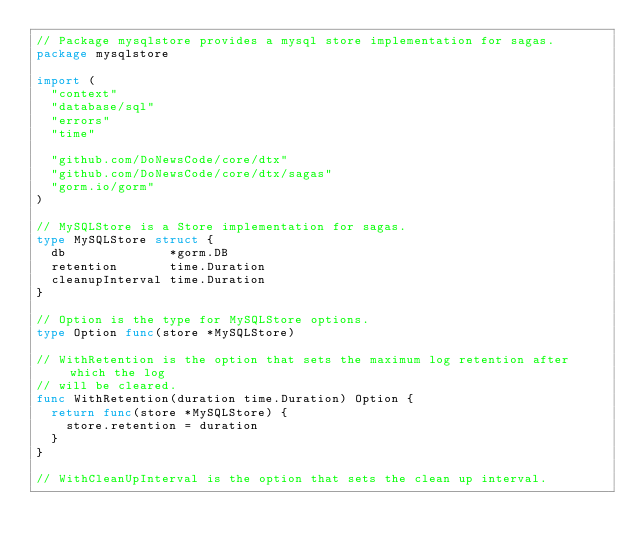<code> <loc_0><loc_0><loc_500><loc_500><_Go_>// Package mysqlstore provides a mysql store implementation for sagas.
package mysqlstore

import (
	"context"
	"database/sql"
	"errors"
	"time"

	"github.com/DoNewsCode/core/dtx"
	"github.com/DoNewsCode/core/dtx/sagas"
	"gorm.io/gorm"
)

// MySQLStore is a Store implementation for sagas.
type MySQLStore struct {
	db              *gorm.DB
	retention       time.Duration
	cleanupInterval time.Duration
}

// Option is the type for MySQLStore options.
type Option func(store *MySQLStore)

// WithRetention is the option that sets the maximum log retention after which the log
// will be cleared.
func WithRetention(duration time.Duration) Option {
	return func(store *MySQLStore) {
		store.retention = duration
	}
}

// WithCleanUpInterval is the option that sets the clean up interval.</code> 